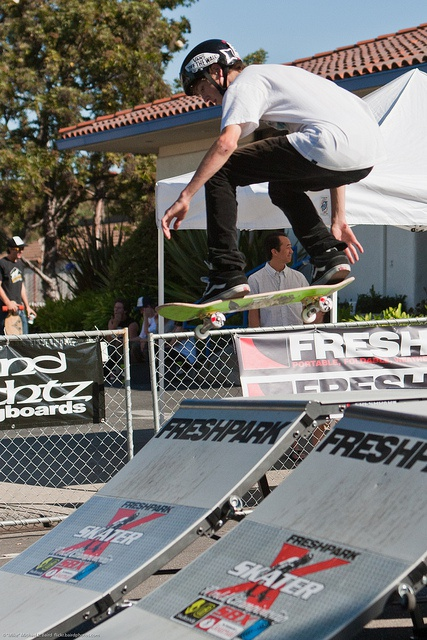Describe the objects in this image and their specific colors. I can see people in black, lightgray, darkgray, and gray tones, skateboard in black, olive, darkgreen, gray, and lightgray tones, people in black, gray, and brown tones, people in black, gray, tan, and maroon tones, and people in black and gray tones in this image. 